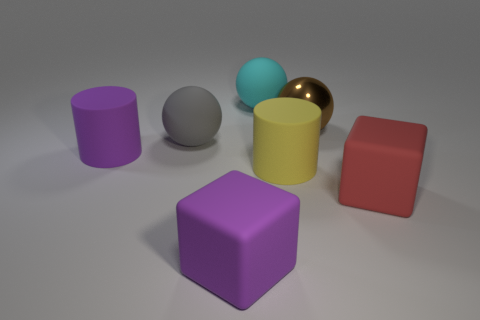Is the number of big brown metallic spheres that are behind the big yellow matte cylinder less than the number of large yellow things?
Your response must be concise. No. Is the large purple cylinder made of the same material as the purple cube?
Make the answer very short. Yes. How many red cubes are the same material as the cyan sphere?
Provide a short and direct response. 1. The cylinder that is the same material as the big yellow thing is what color?
Give a very brief answer. Purple. What is the shape of the large cyan object?
Your response must be concise. Sphere. What is the large cylinder that is on the left side of the large gray thing made of?
Give a very brief answer. Rubber. There is a brown metal object that is the same size as the yellow rubber cylinder; what shape is it?
Offer a very short reply. Sphere. There is a big rubber cube that is left of the large brown sphere; what color is it?
Ensure brevity in your answer.  Purple. There is a yellow matte cylinder in front of the cyan ball; is there a big brown thing on the left side of it?
Your response must be concise. No. What number of objects are large matte cubes that are on the left side of the cyan rubber object or big brown shiny objects?
Make the answer very short. 2. 